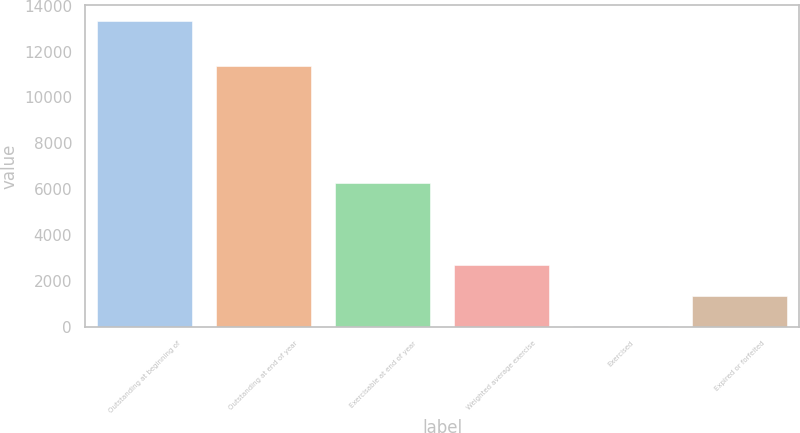Convert chart. <chart><loc_0><loc_0><loc_500><loc_500><bar_chart><fcel>Outstanding at beginning of<fcel>Outstanding at end of year<fcel>Exercisable at end of year<fcel>Weighted average exercise<fcel>Exercised<fcel>Expired or forfeited<nl><fcel>13347<fcel>11392<fcel>6256<fcel>2687.62<fcel>22.78<fcel>1355.2<nl></chart> 